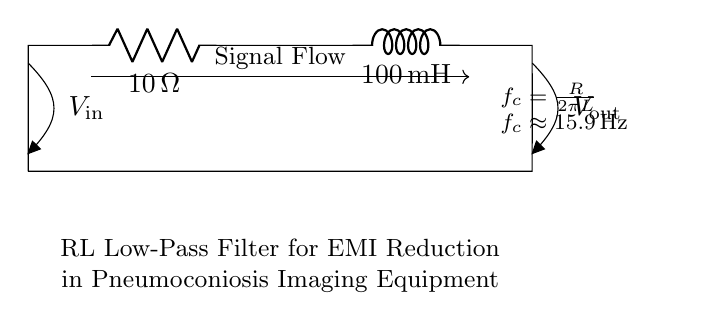What is the resistance value in the circuit? The resistance value is indicated on the resistor in the diagram and is specified as 10 Ohms.
Answer: 10 Ohms What is the inductance value in the circuit? The inductance value is shown on the inductor in the diagram and is specified as 100 millihenries.
Answer: 100 millihenries What is the cutoff frequency of this circuit? The cutoff frequency can be calculated using the formula provided in the diagram, \( f_c = \frac{R}{2\pi L} \). Substituting R = 10 Ohms and L = 100 mH leads to a cutoff frequency of approximately 15.9 Hertz.
Answer: 15.9 Hertz What type of filter does this circuit represent? The circuit is designed as a low-pass filter, as indicated by the configuration of the resistor and inductor, allowing signals below a certain frequency to pass through while attenuating higher frequencies.
Answer: Low-pass filter What does the term EMI stand for in the context of this circuit? EMI refers to Electromagnetic Interference, which is relevant here as the circuit is designed to filter out unwanted electromagnetic signals that may interfere with the imaging equipment.
Answer: Electromagnetic Interference How does the inductor contribute to filtering in this circuit? The inductor stores energy in a magnetic field when current flows through it, allowing it to resist changes in current, thereby filtering out high-frequency signals and letting lower frequencies pass, which is essential for the performance of the low-pass filter.
Answer: Resists high frequencies 